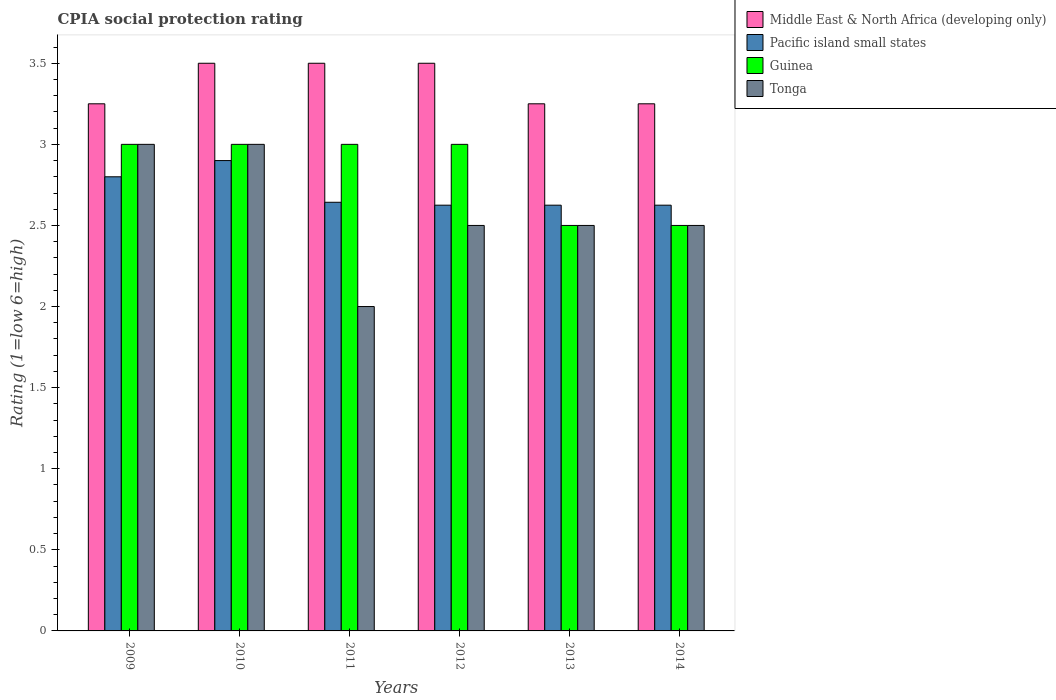How many groups of bars are there?
Keep it short and to the point. 6. Are the number of bars per tick equal to the number of legend labels?
Keep it short and to the point. Yes. How many bars are there on the 2nd tick from the left?
Ensure brevity in your answer.  4. How many bars are there on the 1st tick from the right?
Your response must be concise. 4. Across all years, what is the maximum CPIA rating in Guinea?
Keep it short and to the point. 3. Across all years, what is the minimum CPIA rating in Tonga?
Offer a very short reply. 2. In which year was the CPIA rating in Pacific island small states minimum?
Provide a short and direct response. 2012. What is the total CPIA rating in Tonga in the graph?
Your answer should be compact. 15.5. What is the average CPIA rating in Pacific island small states per year?
Make the answer very short. 2.7. In the year 2014, what is the difference between the CPIA rating in Guinea and CPIA rating in Pacific island small states?
Give a very brief answer. -0.12. In how many years, is the CPIA rating in Guinea greater than 1.9?
Offer a terse response. 6. What is the ratio of the CPIA rating in Pacific island small states in 2011 to that in 2013?
Keep it short and to the point. 1.01. In how many years, is the CPIA rating in Pacific island small states greater than the average CPIA rating in Pacific island small states taken over all years?
Your answer should be very brief. 2. Is it the case that in every year, the sum of the CPIA rating in Pacific island small states and CPIA rating in Guinea is greater than the sum of CPIA rating in Tonga and CPIA rating in Middle East & North Africa (developing only)?
Ensure brevity in your answer.  No. What does the 2nd bar from the left in 2012 represents?
Provide a short and direct response. Pacific island small states. What does the 3rd bar from the right in 2012 represents?
Ensure brevity in your answer.  Pacific island small states. Is it the case that in every year, the sum of the CPIA rating in Tonga and CPIA rating in Guinea is greater than the CPIA rating in Pacific island small states?
Make the answer very short. Yes. How many years are there in the graph?
Keep it short and to the point. 6. Are the values on the major ticks of Y-axis written in scientific E-notation?
Your answer should be very brief. No. Does the graph contain any zero values?
Give a very brief answer. No. Does the graph contain grids?
Provide a short and direct response. No. How are the legend labels stacked?
Make the answer very short. Vertical. What is the title of the graph?
Provide a succinct answer. CPIA social protection rating. What is the label or title of the X-axis?
Offer a very short reply. Years. What is the label or title of the Y-axis?
Offer a terse response. Rating (1=low 6=high). What is the Rating (1=low 6=high) of Middle East & North Africa (developing only) in 2009?
Offer a terse response. 3.25. What is the Rating (1=low 6=high) in Pacific island small states in 2009?
Ensure brevity in your answer.  2.8. What is the Rating (1=low 6=high) in Tonga in 2009?
Make the answer very short. 3. What is the Rating (1=low 6=high) in Pacific island small states in 2010?
Offer a very short reply. 2.9. What is the Rating (1=low 6=high) in Guinea in 2010?
Offer a very short reply. 3. What is the Rating (1=low 6=high) of Middle East & North Africa (developing only) in 2011?
Your answer should be very brief. 3.5. What is the Rating (1=low 6=high) in Pacific island small states in 2011?
Your response must be concise. 2.64. What is the Rating (1=low 6=high) in Guinea in 2011?
Your answer should be compact. 3. What is the Rating (1=low 6=high) in Tonga in 2011?
Your answer should be compact. 2. What is the Rating (1=low 6=high) in Middle East & North Africa (developing only) in 2012?
Your answer should be very brief. 3.5. What is the Rating (1=low 6=high) of Pacific island small states in 2012?
Offer a very short reply. 2.62. What is the Rating (1=low 6=high) of Tonga in 2012?
Make the answer very short. 2.5. What is the Rating (1=low 6=high) of Middle East & North Africa (developing only) in 2013?
Your answer should be compact. 3.25. What is the Rating (1=low 6=high) of Pacific island small states in 2013?
Your answer should be compact. 2.62. What is the Rating (1=low 6=high) of Guinea in 2013?
Ensure brevity in your answer.  2.5. What is the Rating (1=low 6=high) in Tonga in 2013?
Provide a succinct answer. 2.5. What is the Rating (1=low 6=high) of Pacific island small states in 2014?
Your answer should be compact. 2.62. What is the Rating (1=low 6=high) of Guinea in 2014?
Provide a succinct answer. 2.5. Across all years, what is the maximum Rating (1=low 6=high) in Middle East & North Africa (developing only)?
Your answer should be very brief. 3.5. Across all years, what is the maximum Rating (1=low 6=high) in Pacific island small states?
Provide a succinct answer. 2.9. Across all years, what is the minimum Rating (1=low 6=high) of Pacific island small states?
Your answer should be very brief. 2.62. Across all years, what is the minimum Rating (1=low 6=high) in Guinea?
Keep it short and to the point. 2.5. Across all years, what is the minimum Rating (1=low 6=high) of Tonga?
Keep it short and to the point. 2. What is the total Rating (1=low 6=high) of Middle East & North Africa (developing only) in the graph?
Provide a succinct answer. 20.25. What is the total Rating (1=low 6=high) of Pacific island small states in the graph?
Provide a short and direct response. 16.22. What is the total Rating (1=low 6=high) in Guinea in the graph?
Keep it short and to the point. 17. What is the difference between the Rating (1=low 6=high) of Middle East & North Africa (developing only) in 2009 and that in 2010?
Your response must be concise. -0.25. What is the difference between the Rating (1=low 6=high) in Pacific island small states in 2009 and that in 2010?
Provide a short and direct response. -0.1. What is the difference between the Rating (1=low 6=high) of Guinea in 2009 and that in 2010?
Keep it short and to the point. 0. What is the difference between the Rating (1=low 6=high) of Pacific island small states in 2009 and that in 2011?
Make the answer very short. 0.16. What is the difference between the Rating (1=low 6=high) in Pacific island small states in 2009 and that in 2012?
Your answer should be compact. 0.17. What is the difference between the Rating (1=low 6=high) of Guinea in 2009 and that in 2012?
Provide a short and direct response. 0. What is the difference between the Rating (1=low 6=high) in Middle East & North Africa (developing only) in 2009 and that in 2013?
Offer a very short reply. 0. What is the difference between the Rating (1=low 6=high) in Pacific island small states in 2009 and that in 2013?
Give a very brief answer. 0.17. What is the difference between the Rating (1=low 6=high) of Tonga in 2009 and that in 2013?
Your response must be concise. 0.5. What is the difference between the Rating (1=low 6=high) of Middle East & North Africa (developing only) in 2009 and that in 2014?
Provide a short and direct response. 0. What is the difference between the Rating (1=low 6=high) in Pacific island small states in 2009 and that in 2014?
Your response must be concise. 0.17. What is the difference between the Rating (1=low 6=high) in Pacific island small states in 2010 and that in 2011?
Your answer should be very brief. 0.26. What is the difference between the Rating (1=low 6=high) of Guinea in 2010 and that in 2011?
Your answer should be very brief. 0. What is the difference between the Rating (1=low 6=high) in Pacific island small states in 2010 and that in 2012?
Offer a terse response. 0.28. What is the difference between the Rating (1=low 6=high) in Guinea in 2010 and that in 2012?
Provide a short and direct response. 0. What is the difference between the Rating (1=low 6=high) of Tonga in 2010 and that in 2012?
Your answer should be compact. 0.5. What is the difference between the Rating (1=low 6=high) of Middle East & North Africa (developing only) in 2010 and that in 2013?
Ensure brevity in your answer.  0.25. What is the difference between the Rating (1=low 6=high) in Pacific island small states in 2010 and that in 2013?
Your answer should be compact. 0.28. What is the difference between the Rating (1=low 6=high) of Tonga in 2010 and that in 2013?
Provide a short and direct response. 0.5. What is the difference between the Rating (1=low 6=high) of Pacific island small states in 2010 and that in 2014?
Keep it short and to the point. 0.28. What is the difference between the Rating (1=low 6=high) of Guinea in 2010 and that in 2014?
Your answer should be very brief. 0.5. What is the difference between the Rating (1=low 6=high) of Pacific island small states in 2011 and that in 2012?
Your response must be concise. 0.02. What is the difference between the Rating (1=low 6=high) of Tonga in 2011 and that in 2012?
Provide a short and direct response. -0.5. What is the difference between the Rating (1=low 6=high) in Pacific island small states in 2011 and that in 2013?
Provide a short and direct response. 0.02. What is the difference between the Rating (1=low 6=high) of Tonga in 2011 and that in 2013?
Provide a short and direct response. -0.5. What is the difference between the Rating (1=low 6=high) of Pacific island small states in 2011 and that in 2014?
Provide a succinct answer. 0.02. What is the difference between the Rating (1=low 6=high) in Pacific island small states in 2012 and that in 2013?
Ensure brevity in your answer.  0. What is the difference between the Rating (1=low 6=high) in Guinea in 2012 and that in 2013?
Provide a succinct answer. 0.5. What is the difference between the Rating (1=low 6=high) of Guinea in 2012 and that in 2014?
Make the answer very short. 0.5. What is the difference between the Rating (1=low 6=high) of Pacific island small states in 2013 and that in 2014?
Offer a terse response. 0. What is the difference between the Rating (1=low 6=high) of Middle East & North Africa (developing only) in 2009 and the Rating (1=low 6=high) of Pacific island small states in 2010?
Make the answer very short. 0.35. What is the difference between the Rating (1=low 6=high) of Middle East & North Africa (developing only) in 2009 and the Rating (1=low 6=high) of Tonga in 2010?
Give a very brief answer. 0.25. What is the difference between the Rating (1=low 6=high) in Middle East & North Africa (developing only) in 2009 and the Rating (1=low 6=high) in Pacific island small states in 2011?
Offer a very short reply. 0.61. What is the difference between the Rating (1=low 6=high) in Middle East & North Africa (developing only) in 2009 and the Rating (1=low 6=high) in Guinea in 2011?
Provide a short and direct response. 0.25. What is the difference between the Rating (1=low 6=high) in Middle East & North Africa (developing only) in 2009 and the Rating (1=low 6=high) in Tonga in 2011?
Provide a succinct answer. 1.25. What is the difference between the Rating (1=low 6=high) in Pacific island small states in 2009 and the Rating (1=low 6=high) in Guinea in 2011?
Offer a terse response. -0.2. What is the difference between the Rating (1=low 6=high) in Pacific island small states in 2009 and the Rating (1=low 6=high) in Tonga in 2011?
Provide a short and direct response. 0.8. What is the difference between the Rating (1=low 6=high) in Middle East & North Africa (developing only) in 2009 and the Rating (1=low 6=high) in Pacific island small states in 2012?
Give a very brief answer. 0.62. What is the difference between the Rating (1=low 6=high) of Middle East & North Africa (developing only) in 2009 and the Rating (1=low 6=high) of Guinea in 2012?
Your response must be concise. 0.25. What is the difference between the Rating (1=low 6=high) in Middle East & North Africa (developing only) in 2009 and the Rating (1=low 6=high) in Tonga in 2012?
Ensure brevity in your answer.  0.75. What is the difference between the Rating (1=low 6=high) of Pacific island small states in 2009 and the Rating (1=low 6=high) of Guinea in 2012?
Your answer should be very brief. -0.2. What is the difference between the Rating (1=low 6=high) in Guinea in 2009 and the Rating (1=low 6=high) in Tonga in 2012?
Make the answer very short. 0.5. What is the difference between the Rating (1=low 6=high) of Middle East & North Africa (developing only) in 2009 and the Rating (1=low 6=high) of Pacific island small states in 2013?
Your answer should be very brief. 0.62. What is the difference between the Rating (1=low 6=high) of Middle East & North Africa (developing only) in 2009 and the Rating (1=low 6=high) of Guinea in 2013?
Give a very brief answer. 0.75. What is the difference between the Rating (1=low 6=high) in Pacific island small states in 2009 and the Rating (1=low 6=high) in Guinea in 2013?
Provide a succinct answer. 0.3. What is the difference between the Rating (1=low 6=high) in Guinea in 2009 and the Rating (1=low 6=high) in Tonga in 2013?
Keep it short and to the point. 0.5. What is the difference between the Rating (1=low 6=high) of Middle East & North Africa (developing only) in 2009 and the Rating (1=low 6=high) of Pacific island small states in 2014?
Make the answer very short. 0.62. What is the difference between the Rating (1=low 6=high) in Middle East & North Africa (developing only) in 2009 and the Rating (1=low 6=high) in Guinea in 2014?
Make the answer very short. 0.75. What is the difference between the Rating (1=low 6=high) of Middle East & North Africa (developing only) in 2009 and the Rating (1=low 6=high) of Tonga in 2014?
Provide a short and direct response. 0.75. What is the difference between the Rating (1=low 6=high) of Middle East & North Africa (developing only) in 2010 and the Rating (1=low 6=high) of Guinea in 2011?
Give a very brief answer. 0.5. What is the difference between the Rating (1=low 6=high) of Guinea in 2010 and the Rating (1=low 6=high) of Tonga in 2011?
Your answer should be compact. 1. What is the difference between the Rating (1=low 6=high) of Middle East & North Africa (developing only) in 2010 and the Rating (1=low 6=high) of Guinea in 2012?
Offer a very short reply. 0.5. What is the difference between the Rating (1=low 6=high) in Pacific island small states in 2010 and the Rating (1=low 6=high) in Guinea in 2012?
Give a very brief answer. -0.1. What is the difference between the Rating (1=low 6=high) in Pacific island small states in 2010 and the Rating (1=low 6=high) in Tonga in 2012?
Keep it short and to the point. 0.4. What is the difference between the Rating (1=low 6=high) of Guinea in 2010 and the Rating (1=low 6=high) of Tonga in 2012?
Make the answer very short. 0.5. What is the difference between the Rating (1=low 6=high) in Middle East & North Africa (developing only) in 2010 and the Rating (1=low 6=high) in Pacific island small states in 2013?
Your response must be concise. 0.88. What is the difference between the Rating (1=low 6=high) in Middle East & North Africa (developing only) in 2010 and the Rating (1=low 6=high) in Guinea in 2013?
Keep it short and to the point. 1. What is the difference between the Rating (1=low 6=high) of Middle East & North Africa (developing only) in 2010 and the Rating (1=low 6=high) of Tonga in 2013?
Your response must be concise. 1. What is the difference between the Rating (1=low 6=high) of Middle East & North Africa (developing only) in 2010 and the Rating (1=low 6=high) of Tonga in 2014?
Your answer should be compact. 1. What is the difference between the Rating (1=low 6=high) in Pacific island small states in 2010 and the Rating (1=low 6=high) in Guinea in 2014?
Give a very brief answer. 0.4. What is the difference between the Rating (1=low 6=high) of Pacific island small states in 2010 and the Rating (1=low 6=high) of Tonga in 2014?
Ensure brevity in your answer.  0.4. What is the difference between the Rating (1=low 6=high) of Middle East & North Africa (developing only) in 2011 and the Rating (1=low 6=high) of Pacific island small states in 2012?
Keep it short and to the point. 0.88. What is the difference between the Rating (1=low 6=high) of Middle East & North Africa (developing only) in 2011 and the Rating (1=low 6=high) of Guinea in 2012?
Provide a succinct answer. 0.5. What is the difference between the Rating (1=low 6=high) in Middle East & North Africa (developing only) in 2011 and the Rating (1=low 6=high) in Tonga in 2012?
Provide a short and direct response. 1. What is the difference between the Rating (1=low 6=high) of Pacific island small states in 2011 and the Rating (1=low 6=high) of Guinea in 2012?
Your answer should be very brief. -0.36. What is the difference between the Rating (1=low 6=high) of Pacific island small states in 2011 and the Rating (1=low 6=high) of Tonga in 2012?
Your answer should be very brief. 0.14. What is the difference between the Rating (1=low 6=high) in Middle East & North Africa (developing only) in 2011 and the Rating (1=low 6=high) in Tonga in 2013?
Your response must be concise. 1. What is the difference between the Rating (1=low 6=high) in Pacific island small states in 2011 and the Rating (1=low 6=high) in Guinea in 2013?
Your answer should be very brief. 0.14. What is the difference between the Rating (1=low 6=high) in Pacific island small states in 2011 and the Rating (1=low 6=high) in Tonga in 2013?
Your response must be concise. 0.14. What is the difference between the Rating (1=low 6=high) of Middle East & North Africa (developing only) in 2011 and the Rating (1=low 6=high) of Pacific island small states in 2014?
Ensure brevity in your answer.  0.88. What is the difference between the Rating (1=low 6=high) of Pacific island small states in 2011 and the Rating (1=low 6=high) of Guinea in 2014?
Provide a short and direct response. 0.14. What is the difference between the Rating (1=low 6=high) in Pacific island small states in 2011 and the Rating (1=low 6=high) in Tonga in 2014?
Keep it short and to the point. 0.14. What is the difference between the Rating (1=low 6=high) in Middle East & North Africa (developing only) in 2012 and the Rating (1=low 6=high) in Pacific island small states in 2013?
Offer a very short reply. 0.88. What is the difference between the Rating (1=low 6=high) in Pacific island small states in 2012 and the Rating (1=low 6=high) in Guinea in 2013?
Offer a very short reply. 0.12. What is the difference between the Rating (1=low 6=high) of Middle East & North Africa (developing only) in 2012 and the Rating (1=low 6=high) of Pacific island small states in 2014?
Offer a very short reply. 0.88. What is the difference between the Rating (1=low 6=high) of Middle East & North Africa (developing only) in 2013 and the Rating (1=low 6=high) of Guinea in 2014?
Keep it short and to the point. 0.75. What is the difference between the Rating (1=low 6=high) in Pacific island small states in 2013 and the Rating (1=low 6=high) in Tonga in 2014?
Ensure brevity in your answer.  0.12. What is the difference between the Rating (1=low 6=high) of Guinea in 2013 and the Rating (1=low 6=high) of Tonga in 2014?
Provide a succinct answer. 0. What is the average Rating (1=low 6=high) of Middle East & North Africa (developing only) per year?
Make the answer very short. 3.38. What is the average Rating (1=low 6=high) in Pacific island small states per year?
Your answer should be compact. 2.7. What is the average Rating (1=low 6=high) in Guinea per year?
Provide a succinct answer. 2.83. What is the average Rating (1=low 6=high) in Tonga per year?
Make the answer very short. 2.58. In the year 2009, what is the difference between the Rating (1=low 6=high) in Middle East & North Africa (developing only) and Rating (1=low 6=high) in Pacific island small states?
Keep it short and to the point. 0.45. In the year 2009, what is the difference between the Rating (1=low 6=high) in Middle East & North Africa (developing only) and Rating (1=low 6=high) in Guinea?
Keep it short and to the point. 0.25. In the year 2009, what is the difference between the Rating (1=low 6=high) in Middle East & North Africa (developing only) and Rating (1=low 6=high) in Tonga?
Keep it short and to the point. 0.25. In the year 2009, what is the difference between the Rating (1=low 6=high) in Pacific island small states and Rating (1=low 6=high) in Tonga?
Offer a terse response. -0.2. In the year 2010, what is the difference between the Rating (1=low 6=high) in Middle East & North Africa (developing only) and Rating (1=low 6=high) in Guinea?
Provide a short and direct response. 0.5. In the year 2010, what is the difference between the Rating (1=low 6=high) of Middle East & North Africa (developing only) and Rating (1=low 6=high) of Tonga?
Give a very brief answer. 0.5. In the year 2010, what is the difference between the Rating (1=low 6=high) in Pacific island small states and Rating (1=low 6=high) in Tonga?
Provide a short and direct response. -0.1. In the year 2010, what is the difference between the Rating (1=low 6=high) of Guinea and Rating (1=low 6=high) of Tonga?
Provide a succinct answer. 0. In the year 2011, what is the difference between the Rating (1=low 6=high) in Middle East & North Africa (developing only) and Rating (1=low 6=high) in Pacific island small states?
Offer a very short reply. 0.86. In the year 2011, what is the difference between the Rating (1=low 6=high) of Middle East & North Africa (developing only) and Rating (1=low 6=high) of Tonga?
Provide a short and direct response. 1.5. In the year 2011, what is the difference between the Rating (1=low 6=high) of Pacific island small states and Rating (1=low 6=high) of Guinea?
Your response must be concise. -0.36. In the year 2011, what is the difference between the Rating (1=low 6=high) of Pacific island small states and Rating (1=low 6=high) of Tonga?
Offer a terse response. 0.64. In the year 2011, what is the difference between the Rating (1=low 6=high) of Guinea and Rating (1=low 6=high) of Tonga?
Provide a succinct answer. 1. In the year 2012, what is the difference between the Rating (1=low 6=high) in Middle East & North Africa (developing only) and Rating (1=low 6=high) in Pacific island small states?
Keep it short and to the point. 0.88. In the year 2012, what is the difference between the Rating (1=low 6=high) in Middle East & North Africa (developing only) and Rating (1=low 6=high) in Guinea?
Keep it short and to the point. 0.5. In the year 2012, what is the difference between the Rating (1=low 6=high) of Pacific island small states and Rating (1=low 6=high) of Guinea?
Make the answer very short. -0.38. In the year 2012, what is the difference between the Rating (1=low 6=high) of Guinea and Rating (1=low 6=high) of Tonga?
Provide a short and direct response. 0.5. In the year 2013, what is the difference between the Rating (1=low 6=high) in Middle East & North Africa (developing only) and Rating (1=low 6=high) in Pacific island small states?
Your response must be concise. 0.62. In the year 2013, what is the difference between the Rating (1=low 6=high) of Middle East & North Africa (developing only) and Rating (1=low 6=high) of Guinea?
Provide a succinct answer. 0.75. In the year 2013, what is the difference between the Rating (1=low 6=high) in Middle East & North Africa (developing only) and Rating (1=low 6=high) in Tonga?
Keep it short and to the point. 0.75. In the year 2013, what is the difference between the Rating (1=low 6=high) in Guinea and Rating (1=low 6=high) in Tonga?
Offer a very short reply. 0. In the year 2014, what is the difference between the Rating (1=low 6=high) of Middle East & North Africa (developing only) and Rating (1=low 6=high) of Pacific island small states?
Provide a succinct answer. 0.62. In the year 2014, what is the difference between the Rating (1=low 6=high) of Middle East & North Africa (developing only) and Rating (1=low 6=high) of Guinea?
Offer a very short reply. 0.75. In the year 2014, what is the difference between the Rating (1=low 6=high) in Pacific island small states and Rating (1=low 6=high) in Guinea?
Offer a terse response. 0.12. In the year 2014, what is the difference between the Rating (1=low 6=high) of Pacific island small states and Rating (1=low 6=high) of Tonga?
Provide a succinct answer. 0.12. What is the ratio of the Rating (1=low 6=high) in Pacific island small states in 2009 to that in 2010?
Keep it short and to the point. 0.97. What is the ratio of the Rating (1=low 6=high) of Tonga in 2009 to that in 2010?
Ensure brevity in your answer.  1. What is the ratio of the Rating (1=low 6=high) of Middle East & North Africa (developing only) in 2009 to that in 2011?
Make the answer very short. 0.93. What is the ratio of the Rating (1=low 6=high) in Pacific island small states in 2009 to that in 2011?
Offer a terse response. 1.06. What is the ratio of the Rating (1=low 6=high) in Guinea in 2009 to that in 2011?
Offer a terse response. 1. What is the ratio of the Rating (1=low 6=high) of Pacific island small states in 2009 to that in 2012?
Provide a short and direct response. 1.07. What is the ratio of the Rating (1=low 6=high) in Tonga in 2009 to that in 2012?
Your response must be concise. 1.2. What is the ratio of the Rating (1=low 6=high) of Middle East & North Africa (developing only) in 2009 to that in 2013?
Your answer should be compact. 1. What is the ratio of the Rating (1=low 6=high) of Pacific island small states in 2009 to that in 2013?
Provide a succinct answer. 1.07. What is the ratio of the Rating (1=low 6=high) in Pacific island small states in 2009 to that in 2014?
Offer a very short reply. 1.07. What is the ratio of the Rating (1=low 6=high) of Tonga in 2009 to that in 2014?
Provide a short and direct response. 1.2. What is the ratio of the Rating (1=low 6=high) of Middle East & North Africa (developing only) in 2010 to that in 2011?
Your answer should be compact. 1. What is the ratio of the Rating (1=low 6=high) of Pacific island small states in 2010 to that in 2011?
Your answer should be compact. 1.1. What is the ratio of the Rating (1=low 6=high) of Tonga in 2010 to that in 2011?
Your answer should be very brief. 1.5. What is the ratio of the Rating (1=low 6=high) in Middle East & North Africa (developing only) in 2010 to that in 2012?
Your answer should be very brief. 1. What is the ratio of the Rating (1=low 6=high) of Pacific island small states in 2010 to that in 2012?
Your answer should be very brief. 1.1. What is the ratio of the Rating (1=low 6=high) of Pacific island small states in 2010 to that in 2013?
Your response must be concise. 1.1. What is the ratio of the Rating (1=low 6=high) in Guinea in 2010 to that in 2013?
Provide a short and direct response. 1.2. What is the ratio of the Rating (1=low 6=high) in Pacific island small states in 2010 to that in 2014?
Offer a terse response. 1.1. What is the ratio of the Rating (1=low 6=high) of Guinea in 2010 to that in 2014?
Offer a very short reply. 1.2. What is the ratio of the Rating (1=low 6=high) in Tonga in 2010 to that in 2014?
Your answer should be very brief. 1.2. What is the ratio of the Rating (1=low 6=high) in Middle East & North Africa (developing only) in 2011 to that in 2012?
Ensure brevity in your answer.  1. What is the ratio of the Rating (1=low 6=high) of Pacific island small states in 2011 to that in 2012?
Offer a terse response. 1.01. What is the ratio of the Rating (1=low 6=high) of Middle East & North Africa (developing only) in 2011 to that in 2013?
Offer a very short reply. 1.08. What is the ratio of the Rating (1=low 6=high) in Pacific island small states in 2011 to that in 2013?
Offer a very short reply. 1.01. What is the ratio of the Rating (1=low 6=high) in Tonga in 2011 to that in 2013?
Provide a short and direct response. 0.8. What is the ratio of the Rating (1=low 6=high) in Middle East & North Africa (developing only) in 2011 to that in 2014?
Offer a very short reply. 1.08. What is the ratio of the Rating (1=low 6=high) in Pacific island small states in 2011 to that in 2014?
Provide a short and direct response. 1.01. What is the ratio of the Rating (1=low 6=high) of Guinea in 2011 to that in 2014?
Provide a succinct answer. 1.2. What is the ratio of the Rating (1=low 6=high) in Middle East & North Africa (developing only) in 2012 to that in 2013?
Your response must be concise. 1.08. What is the ratio of the Rating (1=low 6=high) in Pacific island small states in 2012 to that in 2013?
Offer a terse response. 1. What is the ratio of the Rating (1=low 6=high) of Tonga in 2012 to that in 2013?
Your answer should be compact. 1. What is the ratio of the Rating (1=low 6=high) of Pacific island small states in 2012 to that in 2014?
Ensure brevity in your answer.  1. What is the ratio of the Rating (1=low 6=high) of Guinea in 2012 to that in 2014?
Give a very brief answer. 1.2. What is the ratio of the Rating (1=low 6=high) of Tonga in 2012 to that in 2014?
Make the answer very short. 1. What is the ratio of the Rating (1=low 6=high) of Middle East & North Africa (developing only) in 2013 to that in 2014?
Ensure brevity in your answer.  1. What is the ratio of the Rating (1=low 6=high) of Guinea in 2013 to that in 2014?
Give a very brief answer. 1. What is the difference between the highest and the second highest Rating (1=low 6=high) in Tonga?
Your answer should be very brief. 0. What is the difference between the highest and the lowest Rating (1=low 6=high) in Middle East & North Africa (developing only)?
Offer a very short reply. 0.25. What is the difference between the highest and the lowest Rating (1=low 6=high) of Pacific island small states?
Provide a succinct answer. 0.28. What is the difference between the highest and the lowest Rating (1=low 6=high) of Guinea?
Your response must be concise. 0.5. What is the difference between the highest and the lowest Rating (1=low 6=high) of Tonga?
Ensure brevity in your answer.  1. 